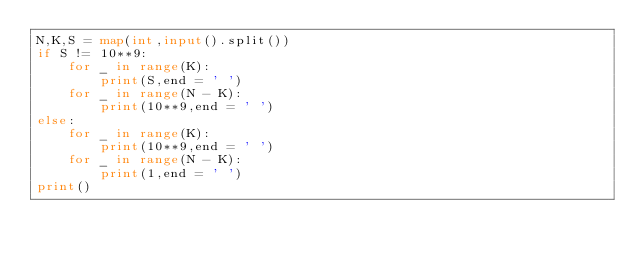Convert code to text. <code><loc_0><loc_0><loc_500><loc_500><_Python_>N,K,S = map(int,input().split())
if S != 10**9:
    for _ in range(K):
        print(S,end = ' ')
    for _ in range(N - K):
        print(10**9,end = ' ')
else:
    for _ in range(K):
        print(10**9,end = ' ')
    for _ in range(N - K):
        print(1,end = ' ')
print()
</code> 